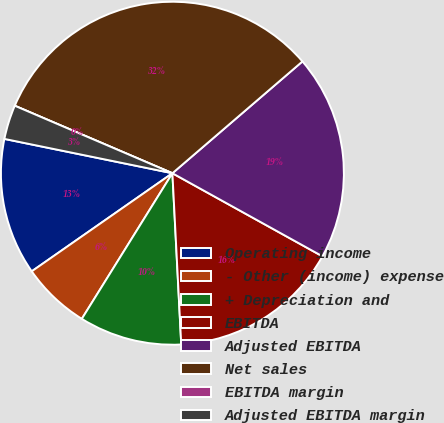Convert chart to OTSL. <chart><loc_0><loc_0><loc_500><loc_500><pie_chart><fcel>Operating income<fcel>- Other (income) expense<fcel>+ Depreciation and<fcel>EBITDA<fcel>Adjusted EBITDA<fcel>Net sales<fcel>EBITDA margin<fcel>Adjusted EBITDA margin<nl><fcel>12.9%<fcel>6.45%<fcel>9.68%<fcel>16.13%<fcel>19.35%<fcel>32.26%<fcel>0.0%<fcel>3.23%<nl></chart> 